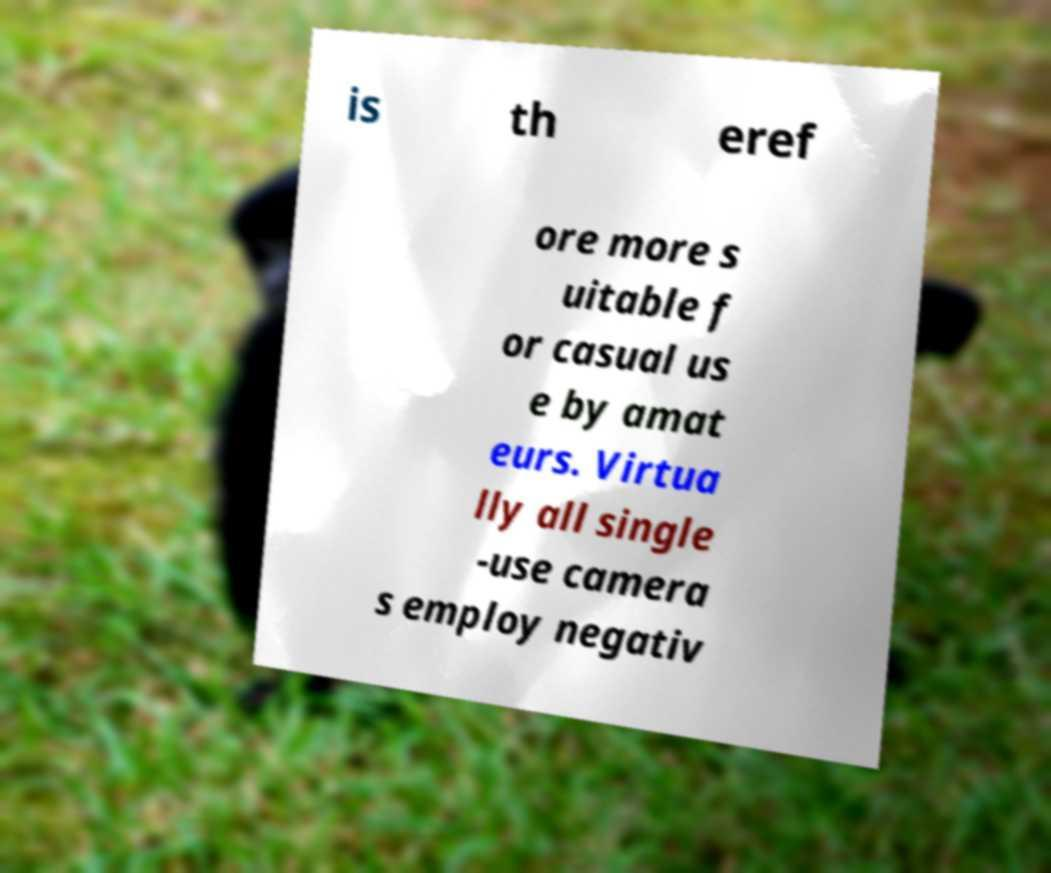There's text embedded in this image that I need extracted. Can you transcribe it verbatim? is th eref ore more s uitable f or casual us e by amat eurs. Virtua lly all single -use camera s employ negativ 